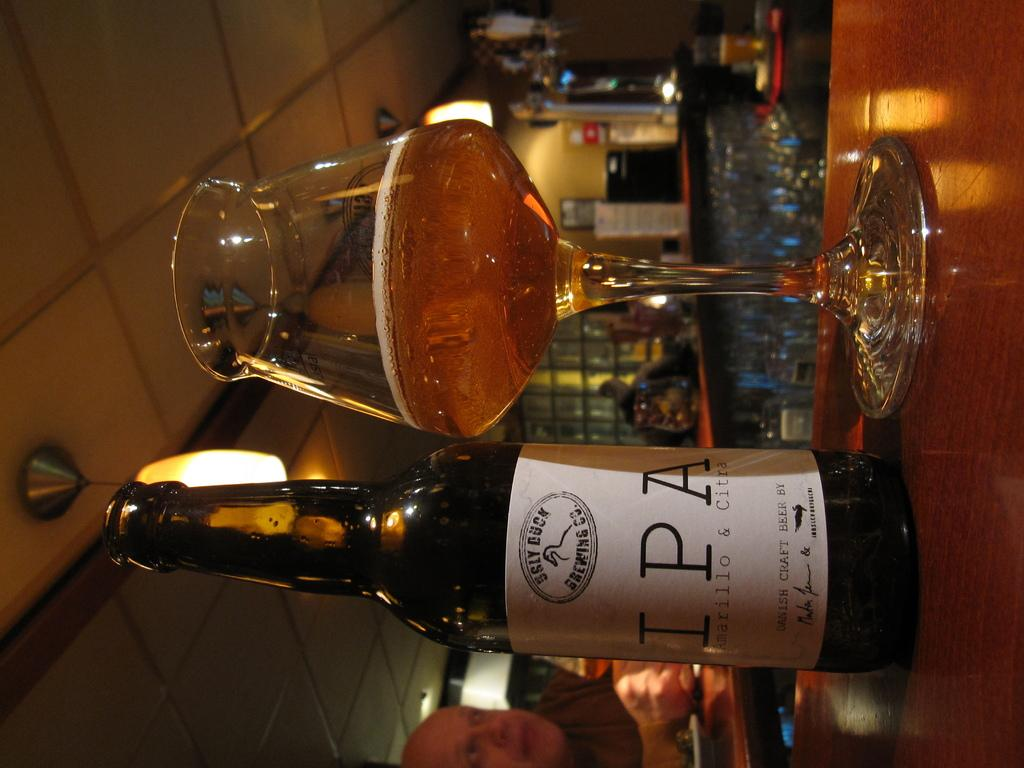<image>
Share a concise interpretation of the image provided. A bottle of Ugly Duck Brewing company Amarillo and citrus IPA with simple white lable next to a nearly empty glass. 